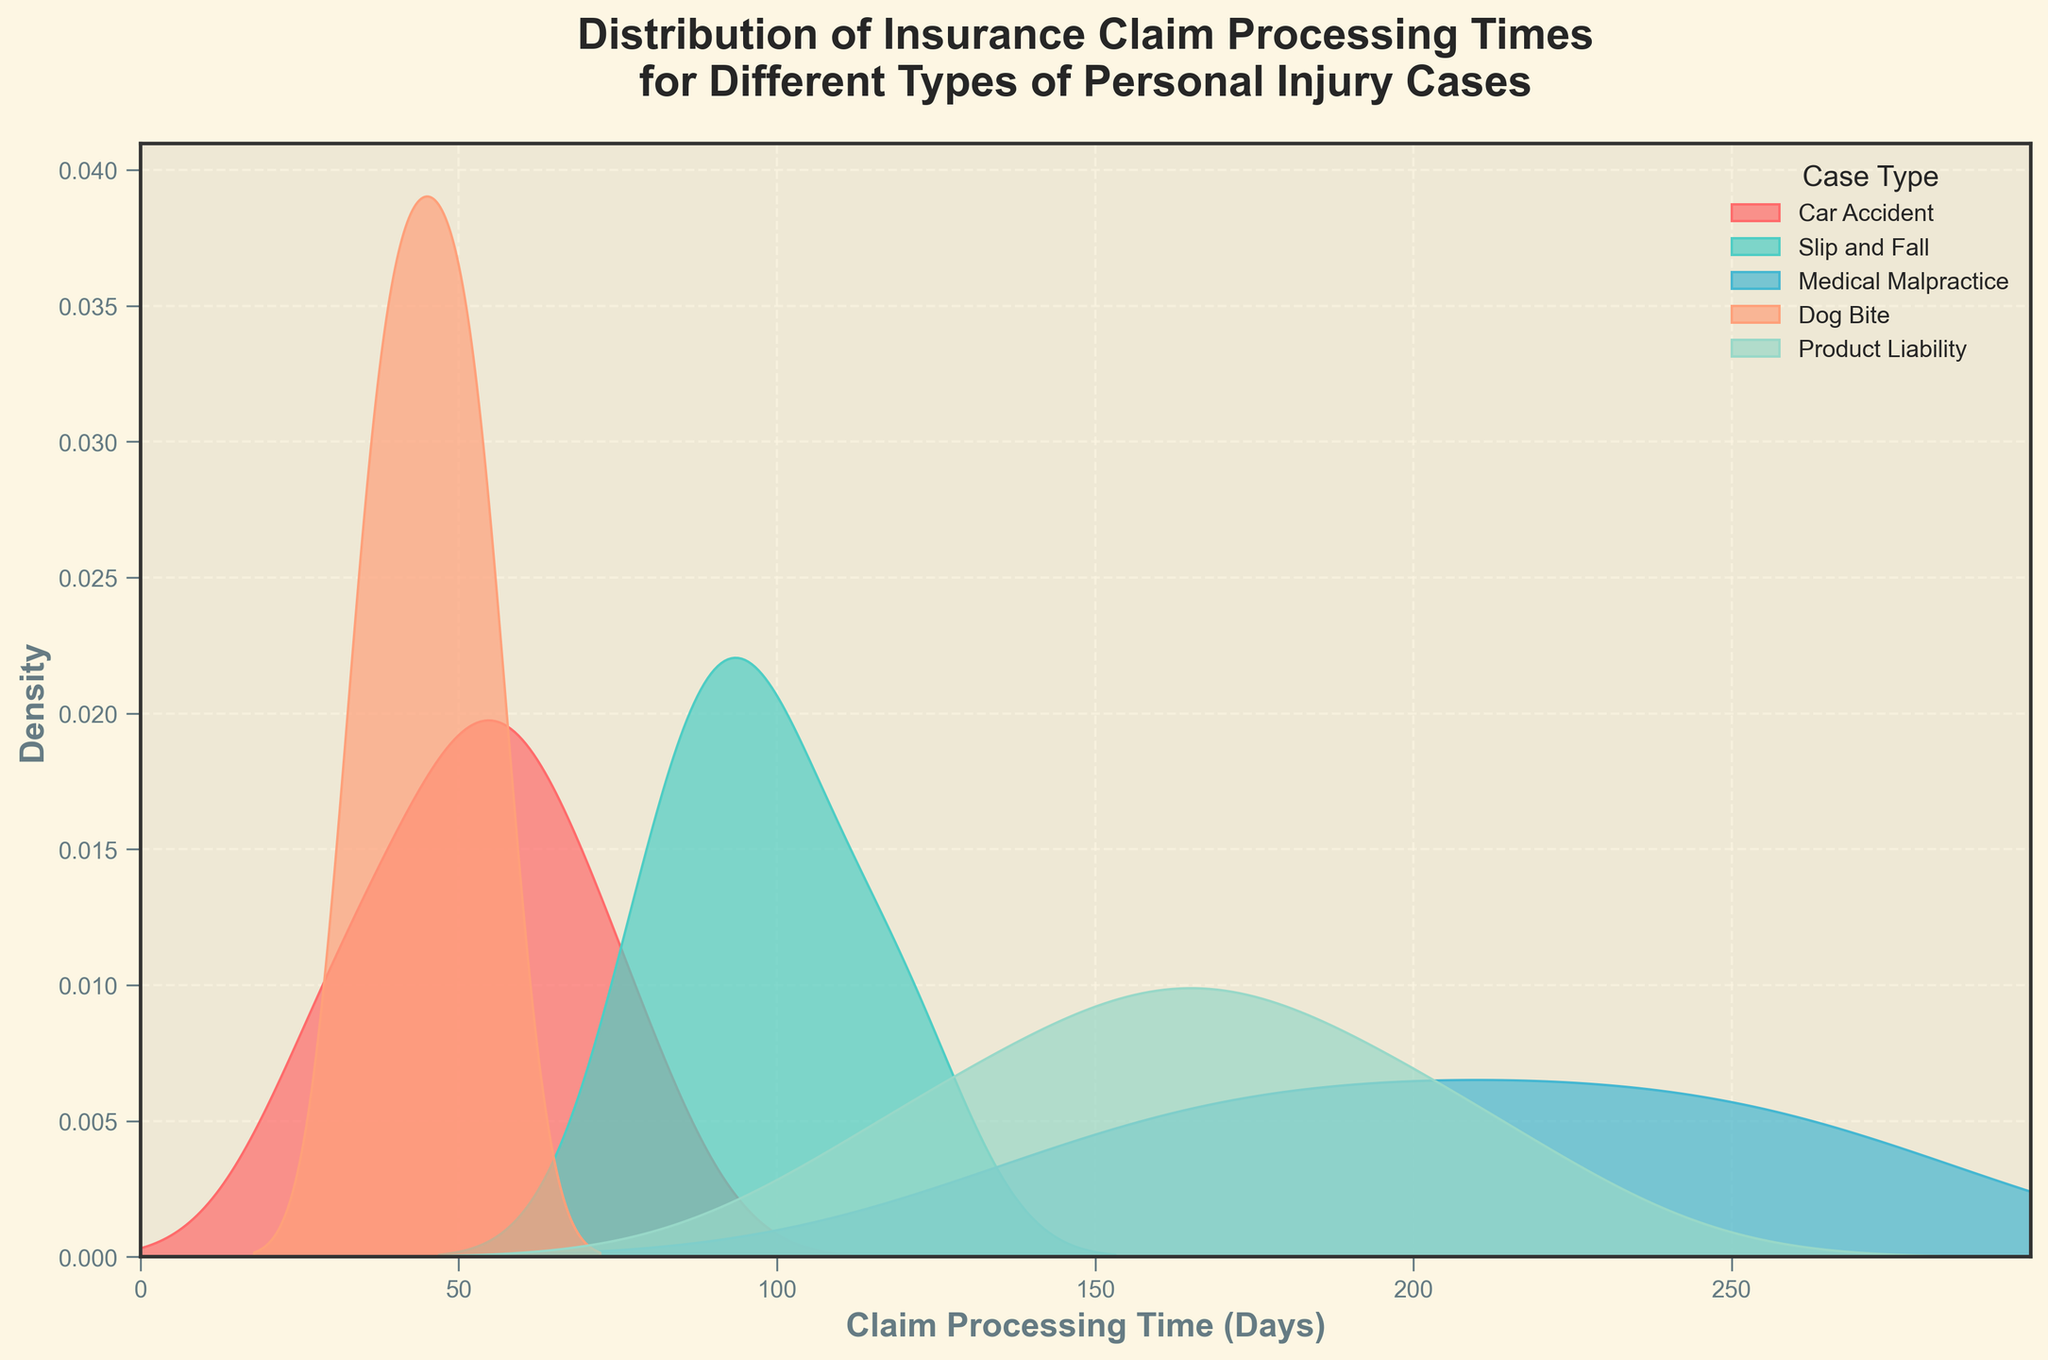What is the title of the figure? The title is usually located at the top of the figure and provides a summary of what the plot is depicting.
Answer: Distribution of Insurance Claim Processing Times for Different Types of Personal Injury Cases Which case type has the highest density peak? By examining the peaks of the density curves, we can identify which one reaches the highest point.
Answer: Slip and Fall What is the typical range of claim processing times for Medical Malpractice cases? Look at the density distribution for Medical Malpractice and identify the range where the density is significant.
Answer: 150-270 days How do the claim processing times for Dog Bite cases compare to Slip and Fall cases? Compare the density curves of Dog Bite and Slip and Fall to see their positions and spreads along the x-axis.
Answer: Dog Bite cases have shorter processing times (35-55 days) compared to Slip and Fall (80-120 days) Which case types have similar claim processing time ranges? Identify case types whose density curves overlap or are close to each other on the x-axis.
Answer: Car Accident and Dog Bite What is the color used for the Car Accident density curve? Identify the color assigned to the density curve labeled as Car Accident.
Answer: A shade of red Which case type has the widest distribution in claim processing times? Look for the case type with a density curve spread across the widest range of the x-axis.
Answer: Medical Malpractice Approximately, how long are the claim processing times for Product Liability cases? Examine the range where the density for Product Liability is significant.
Answer: 120-210 days Which case type has the narrowest claim processing time distribution? Identify the density curve that covers the smallest range on the x-axis.
Answer: Dog Bite 